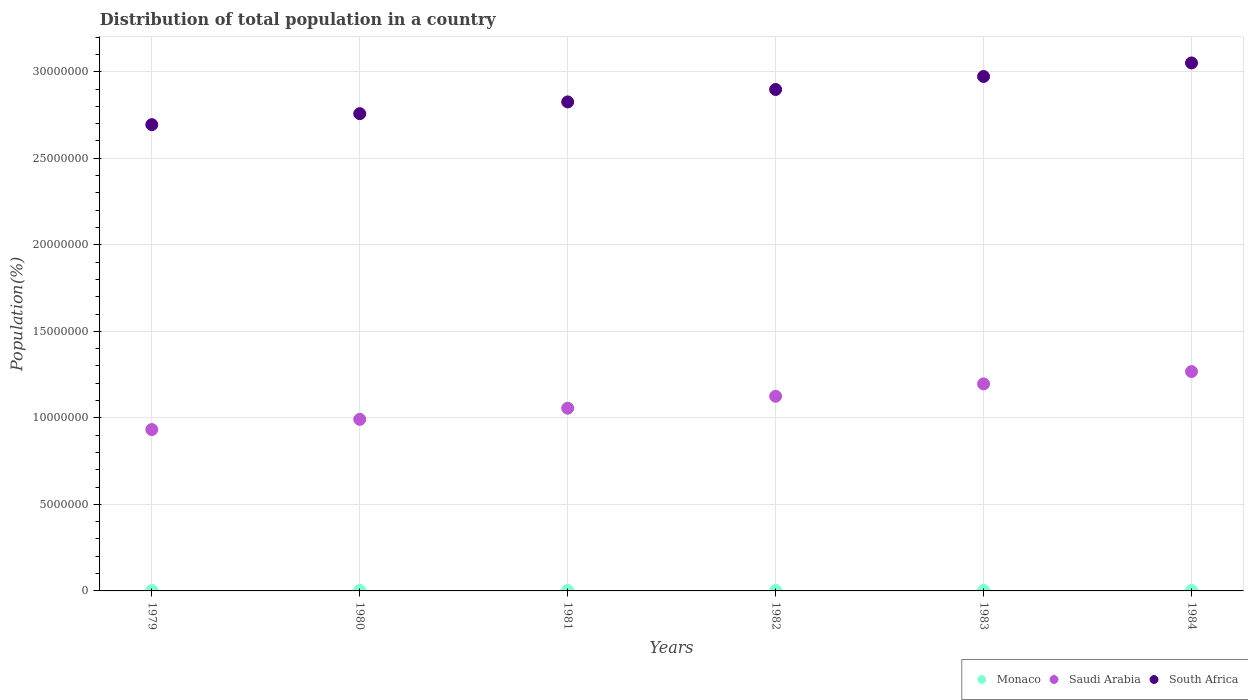How many different coloured dotlines are there?
Provide a short and direct response. 3. Is the number of dotlines equal to the number of legend labels?
Provide a short and direct response. Yes. What is the population of in Saudi Arabia in 1979?
Provide a succinct answer. 9.32e+06. Across all years, what is the maximum population of in Monaco?
Keep it short and to the point. 2.85e+04. Across all years, what is the minimum population of in South Africa?
Provide a short and direct response. 2.69e+07. In which year was the population of in South Africa maximum?
Keep it short and to the point. 1984. In which year was the population of in South Africa minimum?
Your answer should be very brief. 1979. What is the total population of in Saudi Arabia in the graph?
Your response must be concise. 6.57e+07. What is the difference between the population of in Monaco in 1979 and that in 1980?
Keep it short and to the point. -355. What is the difference between the population of in Monaco in 1979 and the population of in South Africa in 1980?
Your answer should be very brief. -2.75e+07. What is the average population of in South Africa per year?
Make the answer very short. 2.87e+07. In the year 1981, what is the difference between the population of in Saudi Arabia and population of in South Africa?
Ensure brevity in your answer.  -1.77e+07. In how many years, is the population of in South Africa greater than 9000000 %?
Provide a succinct answer. 6. What is the ratio of the population of in Monaco in 1979 to that in 1981?
Provide a succinct answer. 0.97. Is the population of in Monaco in 1982 less than that in 1983?
Your answer should be compact. Yes. What is the difference between the highest and the second highest population of in Monaco?
Make the answer very short. 416. What is the difference between the highest and the lowest population of in Monaco?
Make the answer very short. 2123. Is the sum of the population of in South Africa in 1982 and 1984 greater than the maximum population of in Saudi Arabia across all years?
Offer a terse response. Yes. Is it the case that in every year, the sum of the population of in South Africa and population of in Saudi Arabia  is greater than the population of in Monaco?
Provide a short and direct response. Yes. Is the population of in Monaco strictly greater than the population of in Saudi Arabia over the years?
Make the answer very short. No. What is the title of the graph?
Your answer should be compact. Distribution of total population in a country. What is the label or title of the X-axis?
Give a very brief answer. Years. What is the label or title of the Y-axis?
Your response must be concise. Population(%). What is the Population(%) of Monaco in 1979?
Your response must be concise. 2.64e+04. What is the Population(%) in Saudi Arabia in 1979?
Provide a short and direct response. 9.32e+06. What is the Population(%) of South Africa in 1979?
Give a very brief answer. 2.69e+07. What is the Population(%) of Monaco in 1980?
Your answer should be compact. 2.67e+04. What is the Population(%) of Saudi Arabia in 1980?
Offer a very short reply. 9.91e+06. What is the Population(%) of South Africa in 1980?
Offer a terse response. 2.76e+07. What is the Population(%) of Monaco in 1981?
Keep it short and to the point. 2.72e+04. What is the Population(%) of Saudi Arabia in 1981?
Ensure brevity in your answer.  1.06e+07. What is the Population(%) of South Africa in 1981?
Make the answer very short. 2.83e+07. What is the Population(%) of Monaco in 1982?
Make the answer very short. 2.76e+04. What is the Population(%) in Saudi Arabia in 1982?
Your answer should be very brief. 1.12e+07. What is the Population(%) of South Africa in 1982?
Your answer should be very brief. 2.90e+07. What is the Population(%) in Monaco in 1983?
Keep it short and to the point. 2.81e+04. What is the Population(%) of Saudi Arabia in 1983?
Provide a succinct answer. 1.20e+07. What is the Population(%) of South Africa in 1983?
Your answer should be compact. 2.97e+07. What is the Population(%) in Monaco in 1984?
Your answer should be very brief. 2.85e+04. What is the Population(%) of Saudi Arabia in 1984?
Give a very brief answer. 1.27e+07. What is the Population(%) in South Africa in 1984?
Ensure brevity in your answer.  3.05e+07. Across all years, what is the maximum Population(%) in Monaco?
Offer a very short reply. 2.85e+04. Across all years, what is the maximum Population(%) in Saudi Arabia?
Offer a terse response. 1.27e+07. Across all years, what is the maximum Population(%) in South Africa?
Provide a succinct answer. 3.05e+07. Across all years, what is the minimum Population(%) in Monaco?
Provide a succinct answer. 2.64e+04. Across all years, what is the minimum Population(%) in Saudi Arabia?
Keep it short and to the point. 9.32e+06. Across all years, what is the minimum Population(%) of South Africa?
Ensure brevity in your answer.  2.69e+07. What is the total Population(%) in Monaco in the graph?
Offer a very short reply. 1.65e+05. What is the total Population(%) in Saudi Arabia in the graph?
Make the answer very short. 6.57e+07. What is the total Population(%) of South Africa in the graph?
Your answer should be compact. 1.72e+08. What is the difference between the Population(%) in Monaco in 1979 and that in 1980?
Offer a very short reply. -355. What is the difference between the Population(%) of Saudi Arabia in 1979 and that in 1980?
Your response must be concise. -5.90e+05. What is the difference between the Population(%) in South Africa in 1979 and that in 1980?
Make the answer very short. -6.35e+05. What is the difference between the Population(%) of Monaco in 1979 and that in 1981?
Offer a terse response. -774. What is the difference between the Population(%) of Saudi Arabia in 1979 and that in 1981?
Your answer should be compact. -1.23e+06. What is the difference between the Population(%) of South Africa in 1979 and that in 1981?
Provide a succinct answer. -1.31e+06. What is the difference between the Population(%) of Monaco in 1979 and that in 1982?
Your response must be concise. -1238. What is the difference between the Population(%) of Saudi Arabia in 1979 and that in 1982?
Ensure brevity in your answer.  -1.92e+06. What is the difference between the Population(%) of South Africa in 1979 and that in 1982?
Keep it short and to the point. -2.03e+06. What is the difference between the Population(%) of Monaco in 1979 and that in 1983?
Make the answer very short. -1707. What is the difference between the Population(%) in Saudi Arabia in 1979 and that in 1983?
Offer a very short reply. -2.64e+06. What is the difference between the Population(%) of South Africa in 1979 and that in 1983?
Give a very brief answer. -2.78e+06. What is the difference between the Population(%) of Monaco in 1979 and that in 1984?
Provide a short and direct response. -2123. What is the difference between the Population(%) of Saudi Arabia in 1979 and that in 1984?
Ensure brevity in your answer.  -3.35e+06. What is the difference between the Population(%) of South Africa in 1979 and that in 1984?
Provide a succinct answer. -3.56e+06. What is the difference between the Population(%) of Monaco in 1980 and that in 1981?
Your answer should be compact. -419. What is the difference between the Population(%) of Saudi Arabia in 1980 and that in 1981?
Your answer should be very brief. -6.44e+05. What is the difference between the Population(%) in South Africa in 1980 and that in 1981?
Provide a short and direct response. -6.79e+05. What is the difference between the Population(%) in Monaco in 1980 and that in 1982?
Your answer should be very brief. -883. What is the difference between the Population(%) of Saudi Arabia in 1980 and that in 1982?
Keep it short and to the point. -1.33e+06. What is the difference between the Population(%) in South Africa in 1980 and that in 1982?
Keep it short and to the point. -1.40e+06. What is the difference between the Population(%) in Monaco in 1980 and that in 1983?
Keep it short and to the point. -1352. What is the difference between the Population(%) in Saudi Arabia in 1980 and that in 1983?
Your response must be concise. -2.05e+06. What is the difference between the Population(%) in South Africa in 1980 and that in 1983?
Your answer should be very brief. -2.15e+06. What is the difference between the Population(%) in Monaco in 1980 and that in 1984?
Give a very brief answer. -1768. What is the difference between the Population(%) of Saudi Arabia in 1980 and that in 1984?
Your response must be concise. -2.76e+06. What is the difference between the Population(%) in South Africa in 1980 and that in 1984?
Offer a very short reply. -2.93e+06. What is the difference between the Population(%) in Monaco in 1981 and that in 1982?
Keep it short and to the point. -464. What is the difference between the Population(%) in Saudi Arabia in 1981 and that in 1982?
Keep it short and to the point. -6.90e+05. What is the difference between the Population(%) in South Africa in 1981 and that in 1982?
Provide a short and direct response. -7.17e+05. What is the difference between the Population(%) in Monaco in 1981 and that in 1983?
Offer a very short reply. -933. What is the difference between the Population(%) of Saudi Arabia in 1981 and that in 1983?
Give a very brief answer. -1.41e+06. What is the difference between the Population(%) of South Africa in 1981 and that in 1983?
Offer a very short reply. -1.47e+06. What is the difference between the Population(%) of Monaco in 1981 and that in 1984?
Offer a very short reply. -1349. What is the difference between the Population(%) of Saudi Arabia in 1981 and that in 1984?
Make the answer very short. -2.12e+06. What is the difference between the Population(%) in South Africa in 1981 and that in 1984?
Your response must be concise. -2.25e+06. What is the difference between the Population(%) in Monaco in 1982 and that in 1983?
Ensure brevity in your answer.  -469. What is the difference between the Population(%) in Saudi Arabia in 1982 and that in 1983?
Make the answer very short. -7.15e+05. What is the difference between the Population(%) in South Africa in 1982 and that in 1983?
Your response must be concise. -7.52e+05. What is the difference between the Population(%) in Monaco in 1982 and that in 1984?
Offer a terse response. -885. What is the difference between the Population(%) of Saudi Arabia in 1982 and that in 1984?
Offer a terse response. -1.43e+06. What is the difference between the Population(%) in South Africa in 1982 and that in 1984?
Your response must be concise. -1.53e+06. What is the difference between the Population(%) of Monaco in 1983 and that in 1984?
Your answer should be very brief. -416. What is the difference between the Population(%) of Saudi Arabia in 1983 and that in 1984?
Your answer should be compact. -7.12e+05. What is the difference between the Population(%) in South Africa in 1983 and that in 1984?
Keep it short and to the point. -7.81e+05. What is the difference between the Population(%) in Monaco in 1979 and the Population(%) in Saudi Arabia in 1980?
Ensure brevity in your answer.  -9.89e+06. What is the difference between the Population(%) in Monaco in 1979 and the Population(%) in South Africa in 1980?
Provide a succinct answer. -2.75e+07. What is the difference between the Population(%) in Saudi Arabia in 1979 and the Population(%) in South Africa in 1980?
Your answer should be compact. -1.83e+07. What is the difference between the Population(%) in Monaco in 1979 and the Population(%) in Saudi Arabia in 1981?
Your answer should be compact. -1.05e+07. What is the difference between the Population(%) of Monaco in 1979 and the Population(%) of South Africa in 1981?
Ensure brevity in your answer.  -2.82e+07. What is the difference between the Population(%) of Saudi Arabia in 1979 and the Population(%) of South Africa in 1981?
Keep it short and to the point. -1.89e+07. What is the difference between the Population(%) of Monaco in 1979 and the Population(%) of Saudi Arabia in 1982?
Give a very brief answer. -1.12e+07. What is the difference between the Population(%) of Monaco in 1979 and the Population(%) of South Africa in 1982?
Give a very brief answer. -2.89e+07. What is the difference between the Population(%) in Saudi Arabia in 1979 and the Population(%) in South Africa in 1982?
Offer a terse response. -1.96e+07. What is the difference between the Population(%) of Monaco in 1979 and the Population(%) of Saudi Arabia in 1983?
Give a very brief answer. -1.19e+07. What is the difference between the Population(%) in Monaco in 1979 and the Population(%) in South Africa in 1983?
Keep it short and to the point. -2.97e+07. What is the difference between the Population(%) in Saudi Arabia in 1979 and the Population(%) in South Africa in 1983?
Provide a succinct answer. -2.04e+07. What is the difference between the Population(%) in Monaco in 1979 and the Population(%) in Saudi Arabia in 1984?
Offer a terse response. -1.26e+07. What is the difference between the Population(%) in Monaco in 1979 and the Population(%) in South Africa in 1984?
Make the answer very short. -3.05e+07. What is the difference between the Population(%) of Saudi Arabia in 1979 and the Population(%) of South Africa in 1984?
Offer a very short reply. -2.12e+07. What is the difference between the Population(%) in Monaco in 1980 and the Population(%) in Saudi Arabia in 1981?
Your answer should be compact. -1.05e+07. What is the difference between the Population(%) in Monaco in 1980 and the Population(%) in South Africa in 1981?
Offer a terse response. -2.82e+07. What is the difference between the Population(%) of Saudi Arabia in 1980 and the Population(%) of South Africa in 1981?
Provide a succinct answer. -1.83e+07. What is the difference between the Population(%) in Monaco in 1980 and the Population(%) in Saudi Arabia in 1982?
Keep it short and to the point. -1.12e+07. What is the difference between the Population(%) of Monaco in 1980 and the Population(%) of South Africa in 1982?
Offer a very short reply. -2.89e+07. What is the difference between the Population(%) of Saudi Arabia in 1980 and the Population(%) of South Africa in 1982?
Ensure brevity in your answer.  -1.91e+07. What is the difference between the Population(%) of Monaco in 1980 and the Population(%) of Saudi Arabia in 1983?
Provide a short and direct response. -1.19e+07. What is the difference between the Population(%) in Monaco in 1980 and the Population(%) in South Africa in 1983?
Keep it short and to the point. -2.97e+07. What is the difference between the Population(%) in Saudi Arabia in 1980 and the Population(%) in South Africa in 1983?
Your answer should be very brief. -1.98e+07. What is the difference between the Population(%) of Monaco in 1980 and the Population(%) of Saudi Arabia in 1984?
Your answer should be very brief. -1.26e+07. What is the difference between the Population(%) in Monaco in 1980 and the Population(%) in South Africa in 1984?
Provide a succinct answer. -3.05e+07. What is the difference between the Population(%) in Saudi Arabia in 1980 and the Population(%) in South Africa in 1984?
Make the answer very short. -2.06e+07. What is the difference between the Population(%) in Monaco in 1981 and the Population(%) in Saudi Arabia in 1982?
Ensure brevity in your answer.  -1.12e+07. What is the difference between the Population(%) in Monaco in 1981 and the Population(%) in South Africa in 1982?
Provide a succinct answer. -2.89e+07. What is the difference between the Population(%) of Saudi Arabia in 1981 and the Population(%) of South Africa in 1982?
Provide a short and direct response. -1.84e+07. What is the difference between the Population(%) of Monaco in 1981 and the Population(%) of Saudi Arabia in 1983?
Offer a very short reply. -1.19e+07. What is the difference between the Population(%) of Monaco in 1981 and the Population(%) of South Africa in 1983?
Your answer should be compact. -2.97e+07. What is the difference between the Population(%) of Saudi Arabia in 1981 and the Population(%) of South Africa in 1983?
Offer a very short reply. -1.92e+07. What is the difference between the Population(%) in Monaco in 1981 and the Population(%) in Saudi Arabia in 1984?
Give a very brief answer. -1.26e+07. What is the difference between the Population(%) in Monaco in 1981 and the Population(%) in South Africa in 1984?
Ensure brevity in your answer.  -3.05e+07. What is the difference between the Population(%) of Saudi Arabia in 1981 and the Population(%) of South Africa in 1984?
Offer a very short reply. -1.99e+07. What is the difference between the Population(%) in Monaco in 1982 and the Population(%) in Saudi Arabia in 1983?
Provide a succinct answer. -1.19e+07. What is the difference between the Population(%) in Monaco in 1982 and the Population(%) in South Africa in 1983?
Give a very brief answer. -2.97e+07. What is the difference between the Population(%) of Saudi Arabia in 1982 and the Population(%) of South Africa in 1983?
Give a very brief answer. -1.85e+07. What is the difference between the Population(%) of Monaco in 1982 and the Population(%) of Saudi Arabia in 1984?
Make the answer very short. -1.26e+07. What is the difference between the Population(%) of Monaco in 1982 and the Population(%) of South Africa in 1984?
Provide a succinct answer. -3.05e+07. What is the difference between the Population(%) of Saudi Arabia in 1982 and the Population(%) of South Africa in 1984?
Your answer should be compact. -1.93e+07. What is the difference between the Population(%) of Monaco in 1983 and the Population(%) of Saudi Arabia in 1984?
Your answer should be very brief. -1.26e+07. What is the difference between the Population(%) of Monaco in 1983 and the Population(%) of South Africa in 1984?
Make the answer very short. -3.05e+07. What is the difference between the Population(%) in Saudi Arabia in 1983 and the Population(%) in South Africa in 1984?
Provide a short and direct response. -1.85e+07. What is the average Population(%) of Monaco per year?
Offer a terse response. 2.74e+04. What is the average Population(%) in Saudi Arabia per year?
Offer a terse response. 1.09e+07. What is the average Population(%) in South Africa per year?
Keep it short and to the point. 2.87e+07. In the year 1979, what is the difference between the Population(%) of Monaco and Population(%) of Saudi Arabia?
Ensure brevity in your answer.  -9.30e+06. In the year 1979, what is the difference between the Population(%) of Monaco and Population(%) of South Africa?
Keep it short and to the point. -2.69e+07. In the year 1979, what is the difference between the Population(%) of Saudi Arabia and Population(%) of South Africa?
Keep it short and to the point. -1.76e+07. In the year 1980, what is the difference between the Population(%) in Monaco and Population(%) in Saudi Arabia?
Offer a very short reply. -9.89e+06. In the year 1980, what is the difference between the Population(%) in Monaco and Population(%) in South Africa?
Offer a terse response. -2.75e+07. In the year 1980, what is the difference between the Population(%) of Saudi Arabia and Population(%) of South Africa?
Keep it short and to the point. -1.77e+07. In the year 1981, what is the difference between the Population(%) of Monaco and Population(%) of Saudi Arabia?
Provide a succinct answer. -1.05e+07. In the year 1981, what is the difference between the Population(%) in Monaco and Population(%) in South Africa?
Ensure brevity in your answer.  -2.82e+07. In the year 1981, what is the difference between the Population(%) in Saudi Arabia and Population(%) in South Africa?
Provide a succinct answer. -1.77e+07. In the year 1982, what is the difference between the Population(%) in Monaco and Population(%) in Saudi Arabia?
Offer a terse response. -1.12e+07. In the year 1982, what is the difference between the Population(%) in Monaco and Population(%) in South Africa?
Offer a very short reply. -2.89e+07. In the year 1982, what is the difference between the Population(%) in Saudi Arabia and Population(%) in South Africa?
Your answer should be compact. -1.77e+07. In the year 1983, what is the difference between the Population(%) in Monaco and Population(%) in Saudi Arabia?
Provide a succinct answer. -1.19e+07. In the year 1983, what is the difference between the Population(%) of Monaco and Population(%) of South Africa?
Keep it short and to the point. -2.97e+07. In the year 1983, what is the difference between the Population(%) in Saudi Arabia and Population(%) in South Africa?
Provide a short and direct response. -1.78e+07. In the year 1984, what is the difference between the Population(%) of Monaco and Population(%) of Saudi Arabia?
Make the answer very short. -1.26e+07. In the year 1984, what is the difference between the Population(%) in Monaco and Population(%) in South Africa?
Give a very brief answer. -3.05e+07. In the year 1984, what is the difference between the Population(%) in Saudi Arabia and Population(%) in South Africa?
Provide a short and direct response. -1.78e+07. What is the ratio of the Population(%) in Monaco in 1979 to that in 1980?
Keep it short and to the point. 0.99. What is the ratio of the Population(%) of Saudi Arabia in 1979 to that in 1980?
Give a very brief answer. 0.94. What is the ratio of the Population(%) of South Africa in 1979 to that in 1980?
Make the answer very short. 0.98. What is the ratio of the Population(%) in Monaco in 1979 to that in 1981?
Provide a succinct answer. 0.97. What is the ratio of the Population(%) in Saudi Arabia in 1979 to that in 1981?
Your answer should be compact. 0.88. What is the ratio of the Population(%) in South Africa in 1979 to that in 1981?
Give a very brief answer. 0.95. What is the ratio of the Population(%) of Monaco in 1979 to that in 1982?
Provide a succinct answer. 0.96. What is the ratio of the Population(%) in Saudi Arabia in 1979 to that in 1982?
Provide a short and direct response. 0.83. What is the ratio of the Population(%) of South Africa in 1979 to that in 1982?
Offer a very short reply. 0.93. What is the ratio of the Population(%) in Monaco in 1979 to that in 1983?
Give a very brief answer. 0.94. What is the ratio of the Population(%) of Saudi Arabia in 1979 to that in 1983?
Provide a succinct answer. 0.78. What is the ratio of the Population(%) in South Africa in 1979 to that in 1983?
Give a very brief answer. 0.91. What is the ratio of the Population(%) of Monaco in 1979 to that in 1984?
Your answer should be very brief. 0.93. What is the ratio of the Population(%) of Saudi Arabia in 1979 to that in 1984?
Your answer should be very brief. 0.74. What is the ratio of the Population(%) of South Africa in 1979 to that in 1984?
Make the answer very short. 0.88. What is the ratio of the Population(%) of Monaco in 1980 to that in 1981?
Ensure brevity in your answer.  0.98. What is the ratio of the Population(%) in Saudi Arabia in 1980 to that in 1981?
Keep it short and to the point. 0.94. What is the ratio of the Population(%) of Monaco in 1980 to that in 1982?
Give a very brief answer. 0.97. What is the ratio of the Population(%) of Saudi Arabia in 1980 to that in 1982?
Give a very brief answer. 0.88. What is the ratio of the Population(%) of South Africa in 1980 to that in 1982?
Your answer should be very brief. 0.95. What is the ratio of the Population(%) of Monaco in 1980 to that in 1983?
Ensure brevity in your answer.  0.95. What is the ratio of the Population(%) in Saudi Arabia in 1980 to that in 1983?
Your response must be concise. 0.83. What is the ratio of the Population(%) in South Africa in 1980 to that in 1983?
Ensure brevity in your answer.  0.93. What is the ratio of the Population(%) in Monaco in 1980 to that in 1984?
Your answer should be compact. 0.94. What is the ratio of the Population(%) in Saudi Arabia in 1980 to that in 1984?
Ensure brevity in your answer.  0.78. What is the ratio of the Population(%) of South Africa in 1980 to that in 1984?
Provide a succinct answer. 0.9. What is the ratio of the Population(%) in Monaco in 1981 to that in 1982?
Keep it short and to the point. 0.98. What is the ratio of the Population(%) in Saudi Arabia in 1981 to that in 1982?
Your response must be concise. 0.94. What is the ratio of the Population(%) of South Africa in 1981 to that in 1982?
Keep it short and to the point. 0.98. What is the ratio of the Population(%) in Monaco in 1981 to that in 1983?
Your response must be concise. 0.97. What is the ratio of the Population(%) of Saudi Arabia in 1981 to that in 1983?
Offer a very short reply. 0.88. What is the ratio of the Population(%) of South Africa in 1981 to that in 1983?
Provide a short and direct response. 0.95. What is the ratio of the Population(%) of Monaco in 1981 to that in 1984?
Your answer should be compact. 0.95. What is the ratio of the Population(%) in Saudi Arabia in 1981 to that in 1984?
Make the answer very short. 0.83. What is the ratio of the Population(%) of South Africa in 1981 to that in 1984?
Offer a very short reply. 0.93. What is the ratio of the Population(%) in Monaco in 1982 to that in 1983?
Provide a succinct answer. 0.98. What is the ratio of the Population(%) of Saudi Arabia in 1982 to that in 1983?
Give a very brief answer. 0.94. What is the ratio of the Population(%) of South Africa in 1982 to that in 1983?
Your response must be concise. 0.97. What is the ratio of the Population(%) in Saudi Arabia in 1982 to that in 1984?
Give a very brief answer. 0.89. What is the ratio of the Population(%) in South Africa in 1982 to that in 1984?
Offer a terse response. 0.95. What is the ratio of the Population(%) in Monaco in 1983 to that in 1984?
Offer a terse response. 0.99. What is the ratio of the Population(%) in Saudi Arabia in 1983 to that in 1984?
Your answer should be very brief. 0.94. What is the ratio of the Population(%) of South Africa in 1983 to that in 1984?
Your response must be concise. 0.97. What is the difference between the highest and the second highest Population(%) in Monaco?
Provide a short and direct response. 416. What is the difference between the highest and the second highest Population(%) in Saudi Arabia?
Ensure brevity in your answer.  7.12e+05. What is the difference between the highest and the second highest Population(%) of South Africa?
Keep it short and to the point. 7.81e+05. What is the difference between the highest and the lowest Population(%) in Monaco?
Give a very brief answer. 2123. What is the difference between the highest and the lowest Population(%) in Saudi Arabia?
Give a very brief answer. 3.35e+06. What is the difference between the highest and the lowest Population(%) in South Africa?
Offer a terse response. 3.56e+06. 